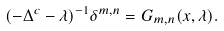<formula> <loc_0><loc_0><loc_500><loc_500>( - \Delta ^ { c } - \lambda ) ^ { - 1 } \delta ^ { m , n } = G _ { m , n } ( x , \lambda ) .</formula> 